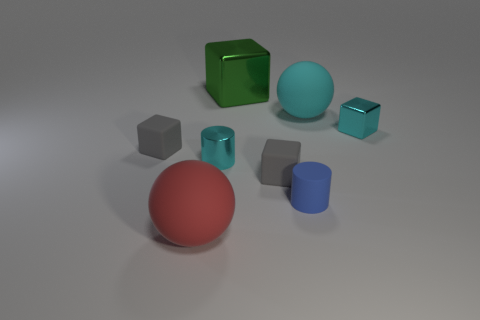There is a red thing that is the same size as the cyan matte sphere; what material is it? The red object that matches the size of the cyan matte sphere appears to be made of rubber, exhibiting a matte surface finish that reflects light in a similar manner to the cyan sphere. 